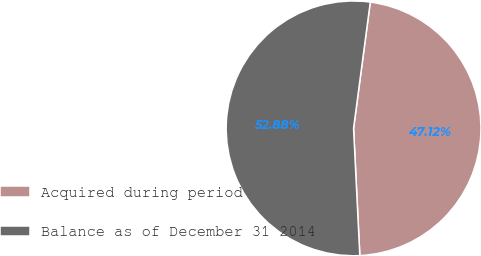Convert chart to OTSL. <chart><loc_0><loc_0><loc_500><loc_500><pie_chart><fcel>Acquired during period<fcel>Balance as of December 31 2014<nl><fcel>47.12%<fcel>52.88%<nl></chart> 